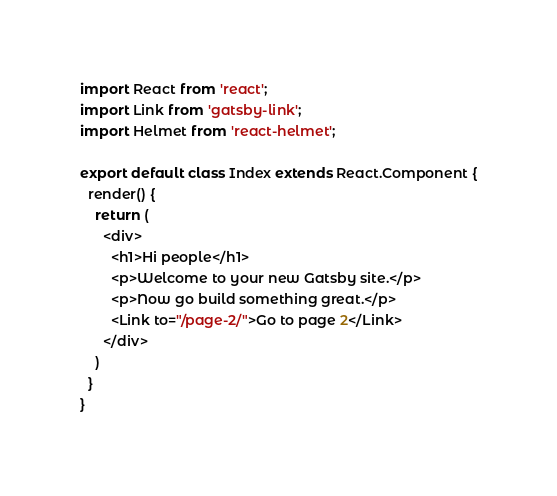<code> <loc_0><loc_0><loc_500><loc_500><_JavaScript_>import React from 'react';
import Link from 'gatsby-link';
import Helmet from 'react-helmet';

export default class Index extends React.Component {
  render() {
    return (
      <div>
        <h1>Hi people</h1>
        <p>Welcome to your new Gatsby site.</p>
        <p>Now go build something great.</p>
        <Link to="/page-2/">Go to page 2</Link>
      </div>
    )
  }
}
</code> 